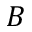Convert formula to latex. <formula><loc_0><loc_0><loc_500><loc_500>B</formula> 